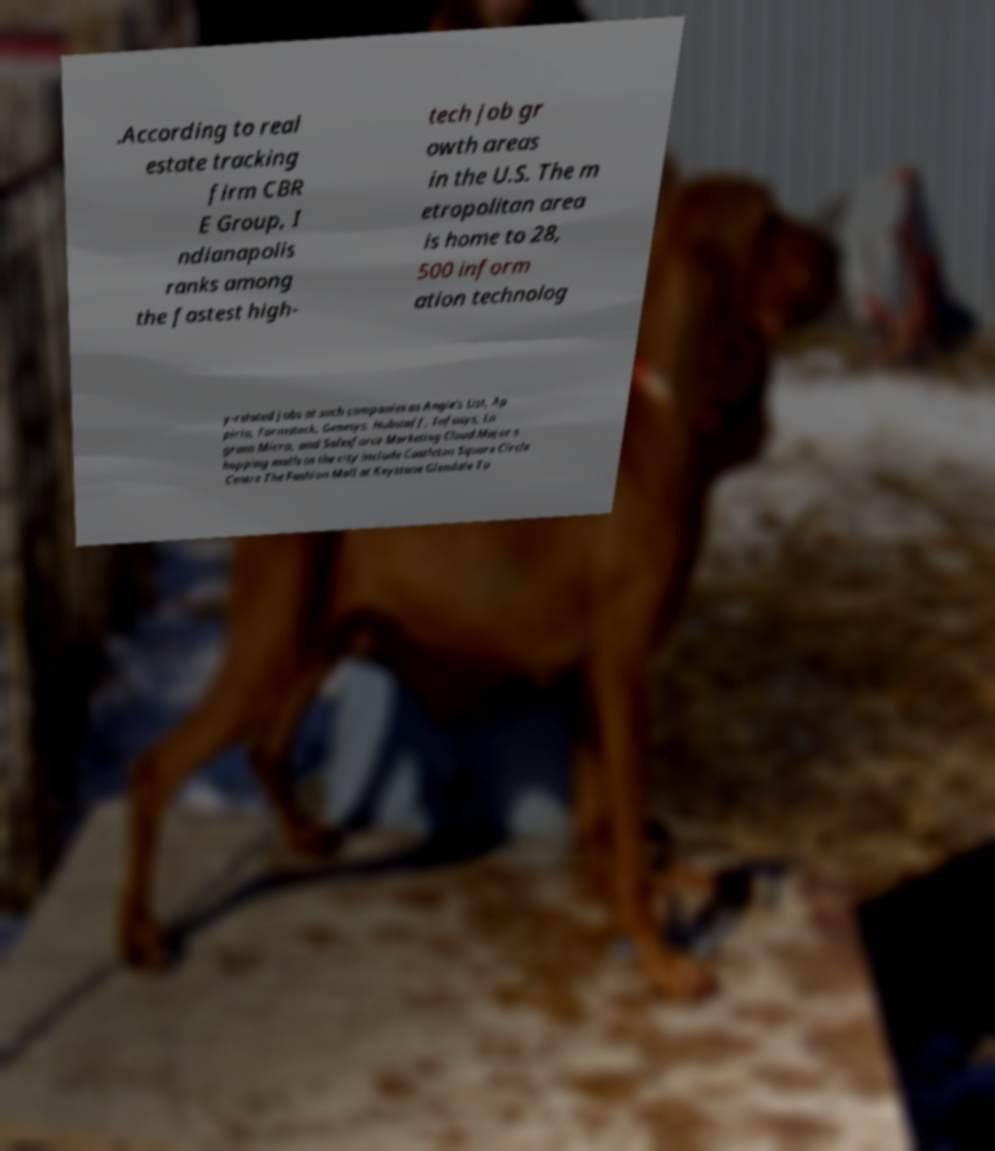What messages or text are displayed in this image? I need them in a readable, typed format. .According to real estate tracking firm CBR E Group, I ndianapolis ranks among the fastest high- tech job gr owth areas in the U.S. The m etropolitan area is home to 28, 500 inform ation technolog y-related jobs at such companies as Angie's List, Ap pirio, Formstack, Genesys, Hubstaff, Infosys, In gram Micro, and Salesforce Marketing Cloud.Major s hopping malls in the city include Castleton Square Circle Centre The Fashion Mall at Keystone Glendale To 